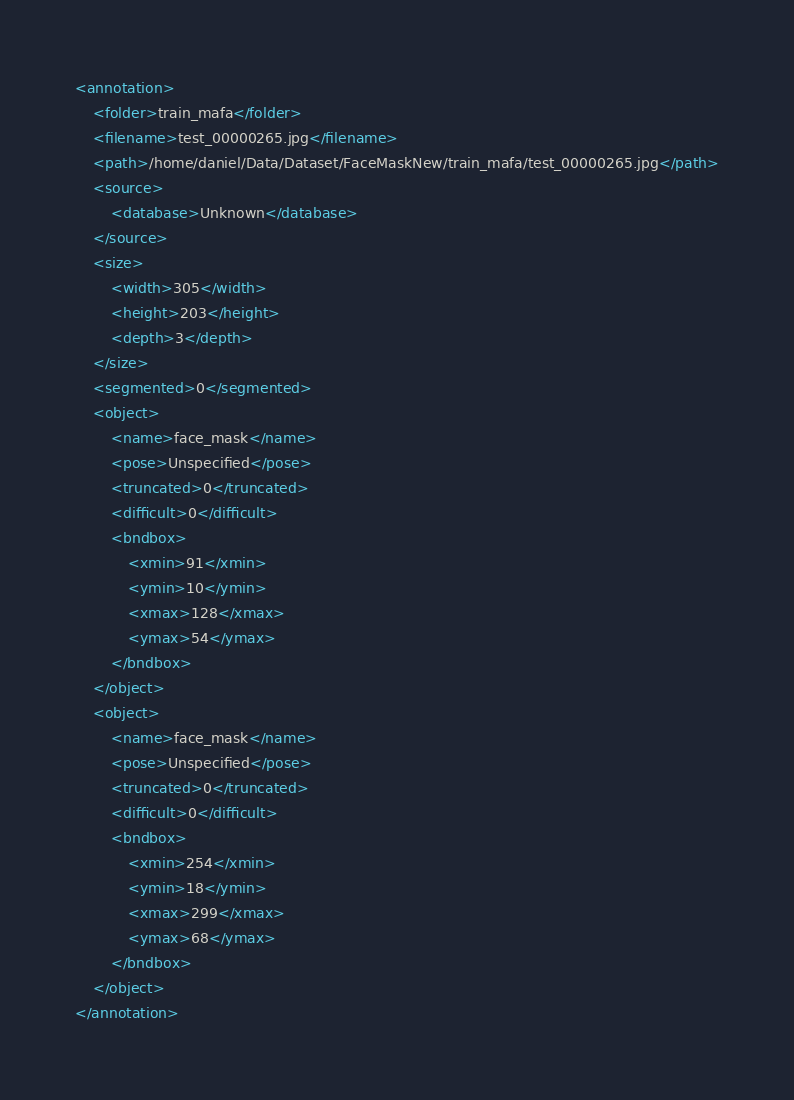<code> <loc_0><loc_0><loc_500><loc_500><_XML_><annotation>
	<folder>train_mafa</folder>
	<filename>test_00000265.jpg</filename>
	<path>/home/daniel/Data/Dataset/FaceMaskNew/train_mafa/test_00000265.jpg</path>
	<source>
		<database>Unknown</database>
	</source>
	<size>
		<width>305</width>
		<height>203</height>
		<depth>3</depth>
	</size>
	<segmented>0</segmented>
	<object>
		<name>face_mask</name>
		<pose>Unspecified</pose>
		<truncated>0</truncated>
		<difficult>0</difficult>
		<bndbox>
			<xmin>91</xmin>
			<ymin>10</ymin>
			<xmax>128</xmax>
			<ymax>54</ymax>
		</bndbox>
	</object>
	<object>
		<name>face_mask</name>
		<pose>Unspecified</pose>
		<truncated>0</truncated>
		<difficult>0</difficult>
		<bndbox>
			<xmin>254</xmin>
			<ymin>18</ymin>
			<xmax>299</xmax>
			<ymax>68</ymax>
		</bndbox>
	</object>
</annotation>
</code> 